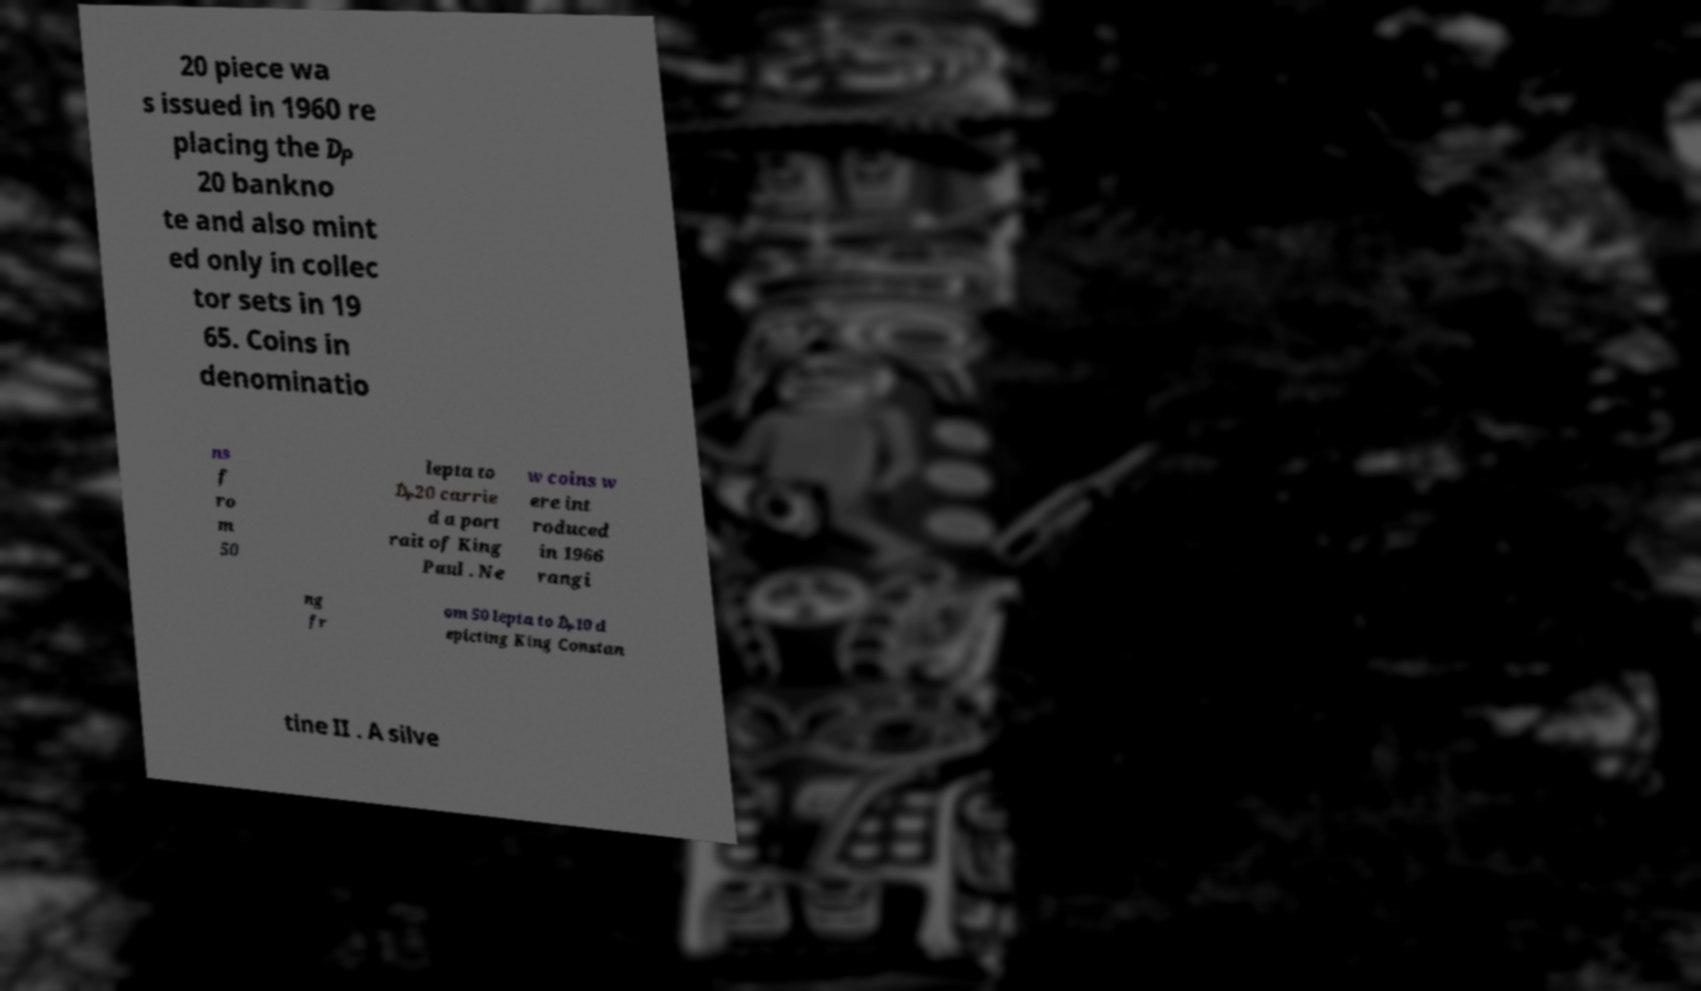I need the written content from this picture converted into text. Can you do that? 20 piece wa s issued in 1960 re placing the ₯ 20 bankno te and also mint ed only in collec tor sets in 19 65. Coins in denominatio ns f ro m 50 lepta to ₯20 carrie d a port rait of King Paul . Ne w coins w ere int roduced in 1966 rangi ng fr om 50 lepta to ₯10 d epicting King Constan tine II . A silve 